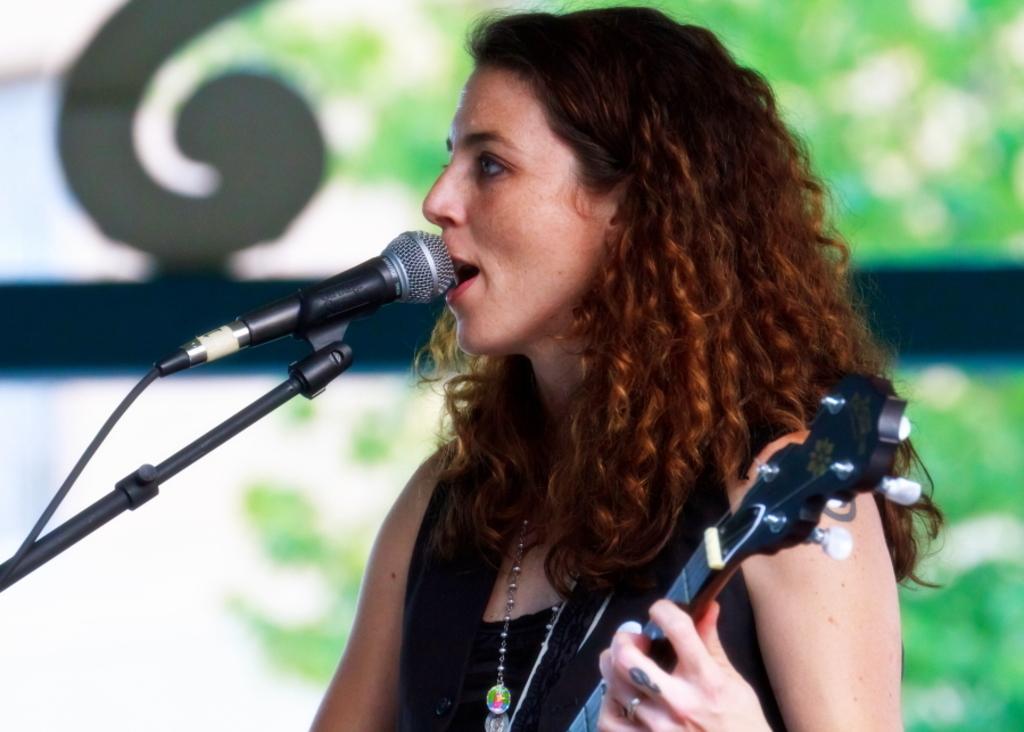Describe this image in one or two sentences. A woman is standing and holding a guitar and singing in front of the microphone and behind her there are trees. 